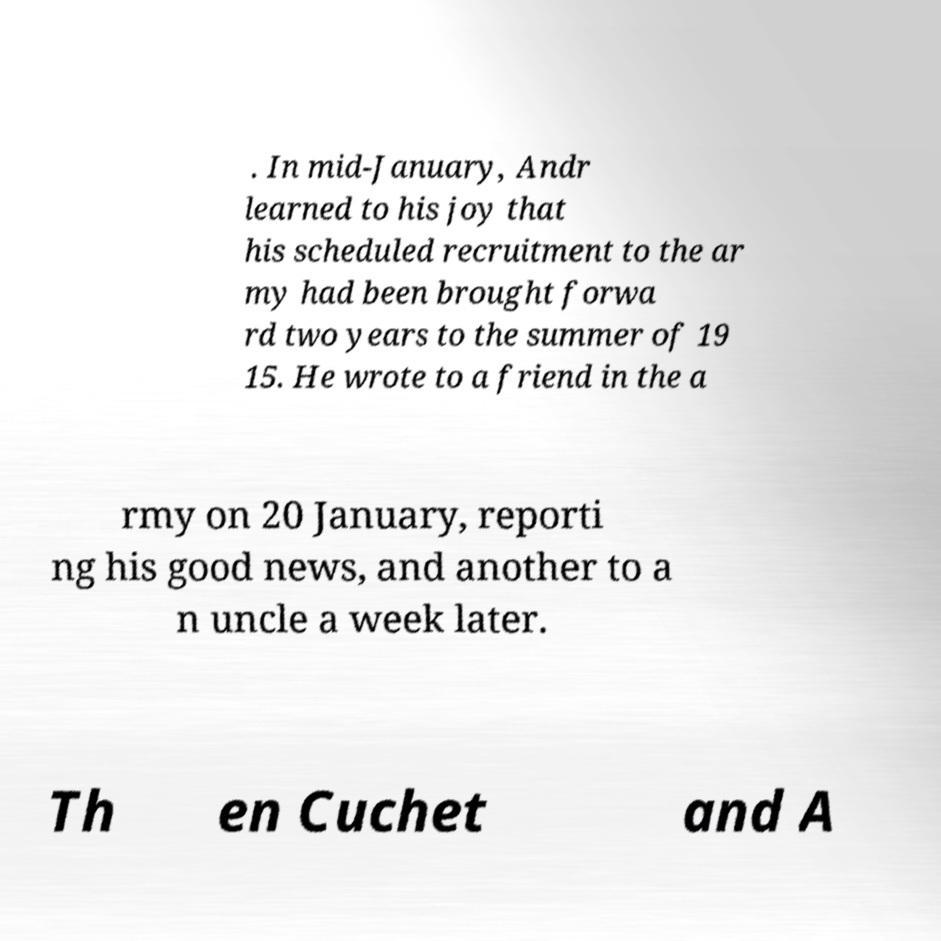What messages or text are displayed in this image? I need them in a readable, typed format. . In mid-January, Andr learned to his joy that his scheduled recruitment to the ar my had been brought forwa rd two years to the summer of 19 15. He wrote to a friend in the a rmy on 20 January, reporti ng his good news, and another to a n uncle a week later. Th en Cuchet and A 